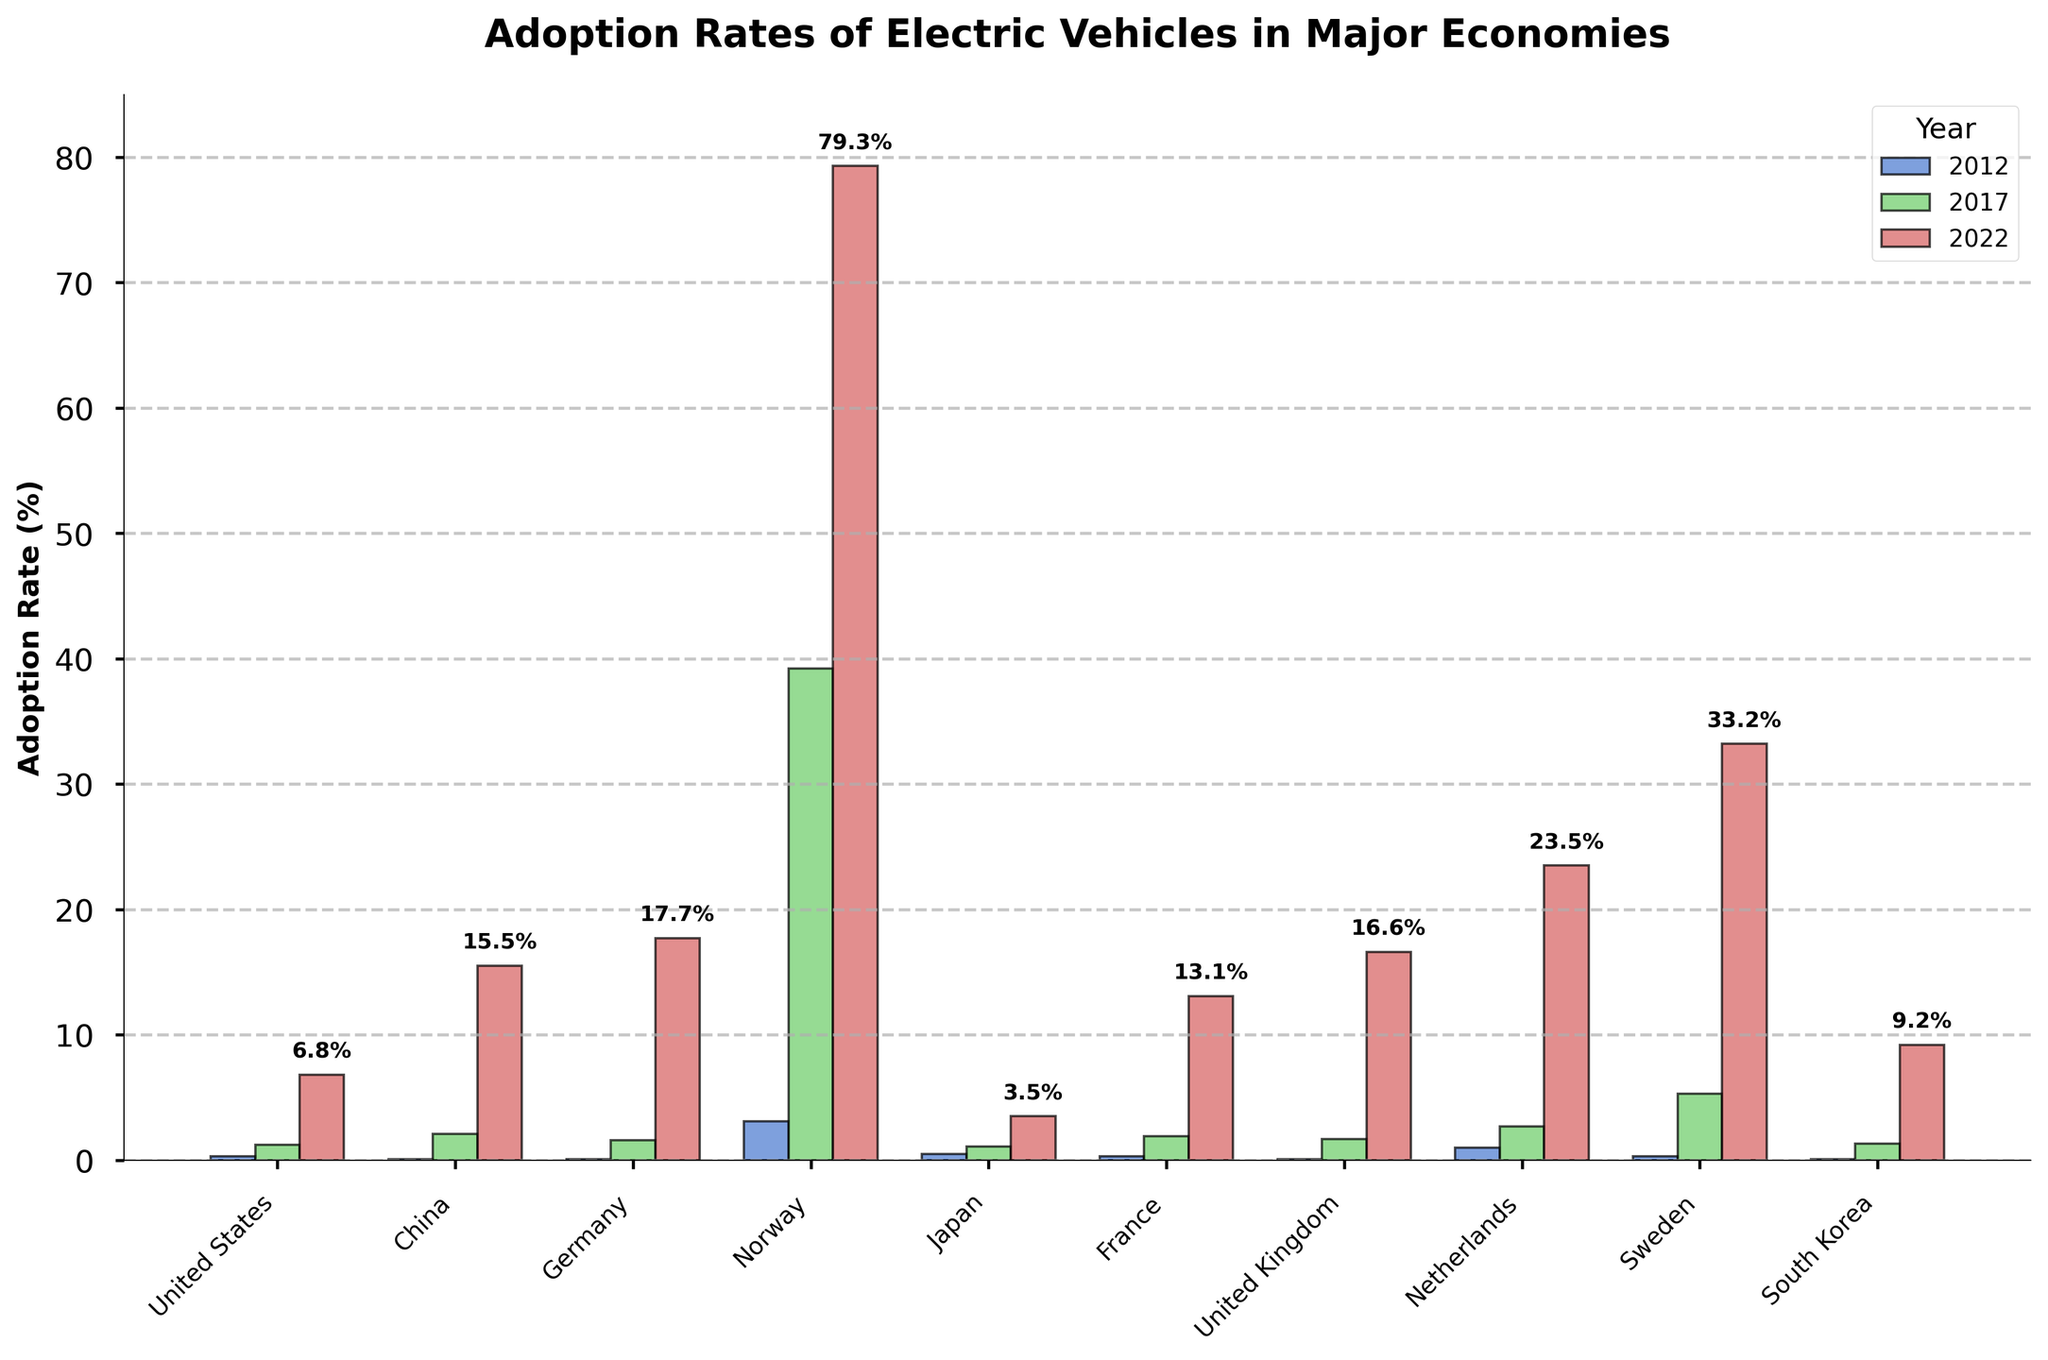What's the country with the highest EV adoption rate in 2022? The tallest bar in 2022 belongs to Norway, which is visually apparent and marked at 79.3%.
Answer: Norway How much did the EV adoption rate in China increase from 2012 to 2022? The adoption rate in China in 2012 was 0.1%, and in 2022 it was 15.5%. The increase is 15.5% - 0.1% = 15.4%.
Answer: 15.4% Which country had the smallest increase in EV adoption rates from 2017 to 2022? By comparing the heights of the bars for 2017 and 2022 for each country, Japan had the smallest increase from 1.1% in 2017 to 3.5% in 2022, which is 3.5% - 1.1% = 2.4%.
Answer: Japan What's the average EV adoption rate across all countries in 2022? Sum the adoption rates for all countries in 2022 and divide by the number of countries: (6.8 + 15.5 + 17.7 + 79.3 + 3.5 + 13.1 + 16.6 + 23.5 + 33.2 + 9.2) / 10 = 21.54%.
Answer: 21.54% Which country showed a greater increase in EV adoption from 2012 to 2022, the United States or the United Kingdom? The US increased from 0.3% in 2012 to 6.8% in 2022 (6.8% - 0.3% = 6.5%), and the UK from 0.1% to 16.6% (16.6% - 0.1% = 16.5%). The UK showed a greater increase.
Answer: United Kingdom How does the EV adoption rate in Germany in 2022 compare to that in Sweden? In 2022, Germany has an adoption rate of 17.7%, and Sweden has 33.2%. Sweden's rate is higher.
Answer: Sweden Which years have the bars with similar heights for any country? In Japan, the bars for 2012 (0.5%) and 2017 (1.1%) have similar heights.
Answer: Japan (2012 and 2017) What is the median EV adoption rate in 2022 among the listed countries? Arrange the adoption rates in 2022 in ascending order and find the middle value. The sorted list is (3.5, 6.8, 9.2, 13.1, 15.5, 16.6, 17.7, 23.5, 33.2, 79.3). The median is the average of the 5th and 6th values: (15.5 + 16.6)/2 = 16.05%.
Answer: 16.05% Between France and the Netherlands, which country had a higher adoption rate in 2017, and by how much? In 2017, France's rate was 1.9% and the Netherlands' was 2.7%. The Netherlands had a higher rate by 2.7% - 1.9% = 0.8%.
Answer: Netherlands by 0.8% 